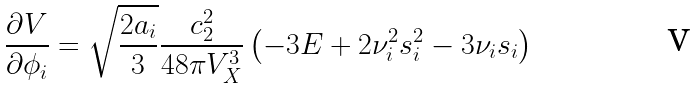<formula> <loc_0><loc_0><loc_500><loc_500>\frac { \partial V } { \partial \phi _ { i } } = \sqrt { \frac { 2 a _ { i } } { 3 } } \frac { c _ { 2 } ^ { 2 } } { 4 8 \pi V _ { X } ^ { 3 } } \left ( - 3 E + 2 \nu _ { i } ^ { 2 } s _ { i } ^ { 2 } - 3 \nu _ { i } s _ { i } \right )</formula> 